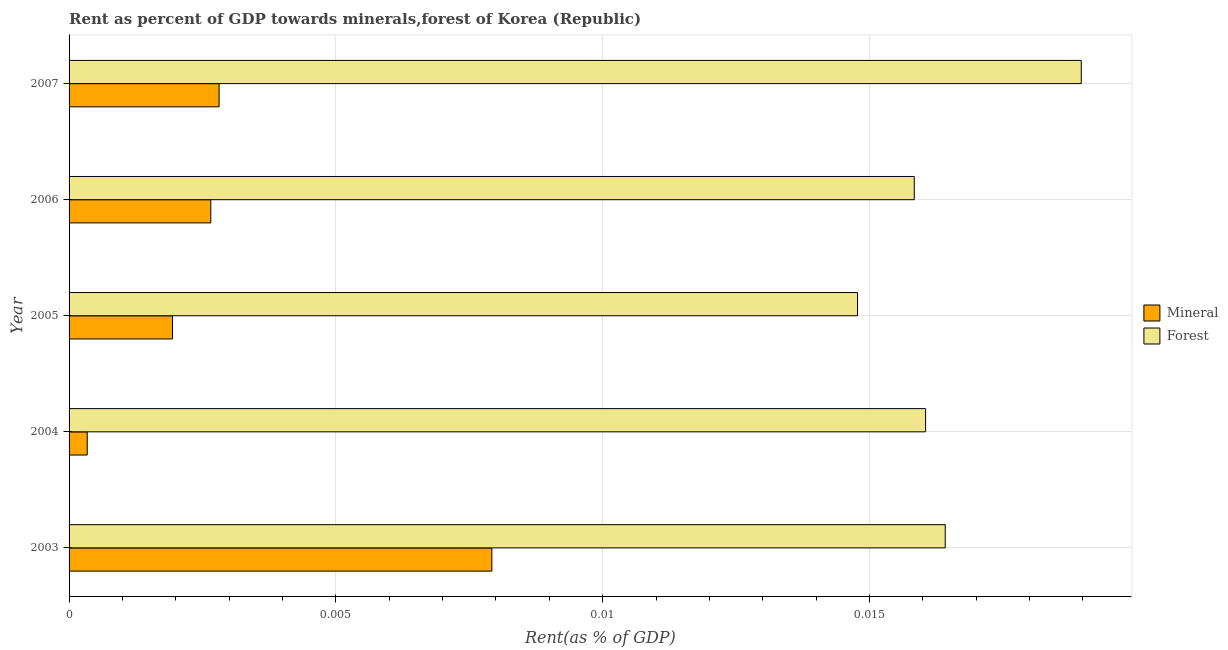How many different coloured bars are there?
Keep it short and to the point. 2. Are the number of bars on each tick of the Y-axis equal?
Your answer should be compact. Yes. How many bars are there on the 5th tick from the top?
Your answer should be very brief. 2. How many bars are there on the 2nd tick from the bottom?
Offer a very short reply. 2. What is the label of the 5th group of bars from the top?
Provide a short and direct response. 2003. What is the mineral rent in 2004?
Ensure brevity in your answer.  0. Across all years, what is the maximum mineral rent?
Provide a short and direct response. 0.01. Across all years, what is the minimum mineral rent?
Your response must be concise. 0. In which year was the forest rent minimum?
Your response must be concise. 2005. What is the total mineral rent in the graph?
Ensure brevity in your answer.  0.02. What is the difference between the forest rent in 2003 and the mineral rent in 2007?
Your response must be concise. 0.01. What is the average mineral rent per year?
Ensure brevity in your answer.  0. In the year 2005, what is the difference between the forest rent and mineral rent?
Offer a terse response. 0.01. In how many years, is the forest rent greater than 0.017 %?
Make the answer very short. 1. What is the ratio of the forest rent in 2004 to that in 2007?
Provide a succinct answer. 0.85. What is the difference between the highest and the second highest forest rent?
Offer a very short reply. 0. In how many years, is the forest rent greater than the average forest rent taken over all years?
Offer a terse response. 2. What does the 2nd bar from the top in 2006 represents?
Keep it short and to the point. Mineral. What does the 2nd bar from the bottom in 2005 represents?
Ensure brevity in your answer.  Forest. How many bars are there?
Ensure brevity in your answer.  10. How many years are there in the graph?
Ensure brevity in your answer.  5. What is the difference between two consecutive major ticks on the X-axis?
Make the answer very short. 0.01. Are the values on the major ticks of X-axis written in scientific E-notation?
Provide a short and direct response. No. Does the graph contain grids?
Offer a very short reply. Yes. Where does the legend appear in the graph?
Give a very brief answer. Center right. How many legend labels are there?
Provide a short and direct response. 2. What is the title of the graph?
Offer a very short reply. Rent as percent of GDP towards minerals,forest of Korea (Republic). Does "Non-residents" appear as one of the legend labels in the graph?
Provide a succinct answer. No. What is the label or title of the X-axis?
Offer a very short reply. Rent(as % of GDP). What is the Rent(as % of GDP) of Mineral in 2003?
Your answer should be very brief. 0.01. What is the Rent(as % of GDP) in Forest in 2003?
Offer a terse response. 0.02. What is the Rent(as % of GDP) in Mineral in 2004?
Give a very brief answer. 0. What is the Rent(as % of GDP) in Forest in 2004?
Provide a short and direct response. 0.02. What is the Rent(as % of GDP) of Mineral in 2005?
Your answer should be very brief. 0. What is the Rent(as % of GDP) in Forest in 2005?
Provide a short and direct response. 0.01. What is the Rent(as % of GDP) of Mineral in 2006?
Provide a short and direct response. 0. What is the Rent(as % of GDP) of Forest in 2006?
Make the answer very short. 0.02. What is the Rent(as % of GDP) of Mineral in 2007?
Your response must be concise. 0. What is the Rent(as % of GDP) in Forest in 2007?
Ensure brevity in your answer.  0.02. Across all years, what is the maximum Rent(as % of GDP) of Mineral?
Give a very brief answer. 0.01. Across all years, what is the maximum Rent(as % of GDP) of Forest?
Ensure brevity in your answer.  0.02. Across all years, what is the minimum Rent(as % of GDP) of Mineral?
Make the answer very short. 0. Across all years, what is the minimum Rent(as % of GDP) in Forest?
Your response must be concise. 0.01. What is the total Rent(as % of GDP) in Mineral in the graph?
Your response must be concise. 0.02. What is the total Rent(as % of GDP) in Forest in the graph?
Your answer should be very brief. 0.08. What is the difference between the Rent(as % of GDP) in Mineral in 2003 and that in 2004?
Your answer should be very brief. 0.01. What is the difference between the Rent(as % of GDP) in Mineral in 2003 and that in 2005?
Offer a terse response. 0.01. What is the difference between the Rent(as % of GDP) in Forest in 2003 and that in 2005?
Provide a succinct answer. 0. What is the difference between the Rent(as % of GDP) in Mineral in 2003 and that in 2006?
Give a very brief answer. 0.01. What is the difference between the Rent(as % of GDP) in Forest in 2003 and that in 2006?
Offer a very short reply. 0. What is the difference between the Rent(as % of GDP) in Mineral in 2003 and that in 2007?
Offer a very short reply. 0.01. What is the difference between the Rent(as % of GDP) of Forest in 2003 and that in 2007?
Your answer should be very brief. -0. What is the difference between the Rent(as % of GDP) in Mineral in 2004 and that in 2005?
Provide a succinct answer. -0. What is the difference between the Rent(as % of GDP) of Forest in 2004 and that in 2005?
Your answer should be compact. 0. What is the difference between the Rent(as % of GDP) in Mineral in 2004 and that in 2006?
Provide a short and direct response. -0. What is the difference between the Rent(as % of GDP) in Forest in 2004 and that in 2006?
Your answer should be very brief. 0. What is the difference between the Rent(as % of GDP) in Mineral in 2004 and that in 2007?
Offer a very short reply. -0. What is the difference between the Rent(as % of GDP) in Forest in 2004 and that in 2007?
Ensure brevity in your answer.  -0. What is the difference between the Rent(as % of GDP) of Mineral in 2005 and that in 2006?
Your response must be concise. -0. What is the difference between the Rent(as % of GDP) in Forest in 2005 and that in 2006?
Your answer should be compact. -0. What is the difference between the Rent(as % of GDP) of Mineral in 2005 and that in 2007?
Ensure brevity in your answer.  -0. What is the difference between the Rent(as % of GDP) in Forest in 2005 and that in 2007?
Offer a terse response. -0. What is the difference between the Rent(as % of GDP) in Mineral in 2006 and that in 2007?
Provide a succinct answer. -0. What is the difference between the Rent(as % of GDP) of Forest in 2006 and that in 2007?
Provide a short and direct response. -0. What is the difference between the Rent(as % of GDP) of Mineral in 2003 and the Rent(as % of GDP) of Forest in 2004?
Provide a short and direct response. -0.01. What is the difference between the Rent(as % of GDP) in Mineral in 2003 and the Rent(as % of GDP) in Forest in 2005?
Your answer should be compact. -0.01. What is the difference between the Rent(as % of GDP) in Mineral in 2003 and the Rent(as % of GDP) in Forest in 2006?
Give a very brief answer. -0.01. What is the difference between the Rent(as % of GDP) of Mineral in 2003 and the Rent(as % of GDP) of Forest in 2007?
Give a very brief answer. -0.01. What is the difference between the Rent(as % of GDP) in Mineral in 2004 and the Rent(as % of GDP) in Forest in 2005?
Give a very brief answer. -0.01. What is the difference between the Rent(as % of GDP) in Mineral in 2004 and the Rent(as % of GDP) in Forest in 2006?
Provide a short and direct response. -0.02. What is the difference between the Rent(as % of GDP) of Mineral in 2004 and the Rent(as % of GDP) of Forest in 2007?
Your answer should be compact. -0.02. What is the difference between the Rent(as % of GDP) of Mineral in 2005 and the Rent(as % of GDP) of Forest in 2006?
Your response must be concise. -0.01. What is the difference between the Rent(as % of GDP) in Mineral in 2005 and the Rent(as % of GDP) in Forest in 2007?
Offer a terse response. -0.02. What is the difference between the Rent(as % of GDP) of Mineral in 2006 and the Rent(as % of GDP) of Forest in 2007?
Your answer should be compact. -0.02. What is the average Rent(as % of GDP) in Mineral per year?
Your response must be concise. 0. What is the average Rent(as % of GDP) of Forest per year?
Provide a succinct answer. 0.02. In the year 2003, what is the difference between the Rent(as % of GDP) of Mineral and Rent(as % of GDP) of Forest?
Your answer should be compact. -0.01. In the year 2004, what is the difference between the Rent(as % of GDP) of Mineral and Rent(as % of GDP) of Forest?
Keep it short and to the point. -0.02. In the year 2005, what is the difference between the Rent(as % of GDP) in Mineral and Rent(as % of GDP) in Forest?
Your response must be concise. -0.01. In the year 2006, what is the difference between the Rent(as % of GDP) of Mineral and Rent(as % of GDP) of Forest?
Your response must be concise. -0.01. In the year 2007, what is the difference between the Rent(as % of GDP) of Mineral and Rent(as % of GDP) of Forest?
Make the answer very short. -0.02. What is the ratio of the Rent(as % of GDP) of Mineral in 2003 to that in 2004?
Keep it short and to the point. 23.29. What is the ratio of the Rent(as % of GDP) of Forest in 2003 to that in 2004?
Provide a short and direct response. 1.02. What is the ratio of the Rent(as % of GDP) of Mineral in 2003 to that in 2005?
Make the answer very short. 4.09. What is the ratio of the Rent(as % of GDP) of Forest in 2003 to that in 2005?
Provide a succinct answer. 1.11. What is the ratio of the Rent(as % of GDP) of Mineral in 2003 to that in 2006?
Give a very brief answer. 2.98. What is the ratio of the Rent(as % of GDP) of Forest in 2003 to that in 2006?
Keep it short and to the point. 1.04. What is the ratio of the Rent(as % of GDP) of Mineral in 2003 to that in 2007?
Make the answer very short. 2.82. What is the ratio of the Rent(as % of GDP) of Forest in 2003 to that in 2007?
Ensure brevity in your answer.  0.87. What is the ratio of the Rent(as % of GDP) of Mineral in 2004 to that in 2005?
Offer a very short reply. 0.18. What is the ratio of the Rent(as % of GDP) in Forest in 2004 to that in 2005?
Ensure brevity in your answer.  1.09. What is the ratio of the Rent(as % of GDP) in Mineral in 2004 to that in 2006?
Provide a short and direct response. 0.13. What is the ratio of the Rent(as % of GDP) of Forest in 2004 to that in 2006?
Make the answer very short. 1.01. What is the ratio of the Rent(as % of GDP) in Mineral in 2004 to that in 2007?
Give a very brief answer. 0.12. What is the ratio of the Rent(as % of GDP) in Forest in 2004 to that in 2007?
Offer a terse response. 0.85. What is the ratio of the Rent(as % of GDP) of Mineral in 2005 to that in 2006?
Your response must be concise. 0.73. What is the ratio of the Rent(as % of GDP) of Forest in 2005 to that in 2006?
Give a very brief answer. 0.93. What is the ratio of the Rent(as % of GDP) in Mineral in 2005 to that in 2007?
Your answer should be compact. 0.69. What is the ratio of the Rent(as % of GDP) of Forest in 2005 to that in 2007?
Provide a succinct answer. 0.78. What is the ratio of the Rent(as % of GDP) in Mineral in 2006 to that in 2007?
Ensure brevity in your answer.  0.94. What is the ratio of the Rent(as % of GDP) in Forest in 2006 to that in 2007?
Ensure brevity in your answer.  0.83. What is the difference between the highest and the second highest Rent(as % of GDP) in Mineral?
Offer a very short reply. 0.01. What is the difference between the highest and the second highest Rent(as % of GDP) in Forest?
Offer a terse response. 0. What is the difference between the highest and the lowest Rent(as % of GDP) of Mineral?
Offer a very short reply. 0.01. What is the difference between the highest and the lowest Rent(as % of GDP) of Forest?
Give a very brief answer. 0. 